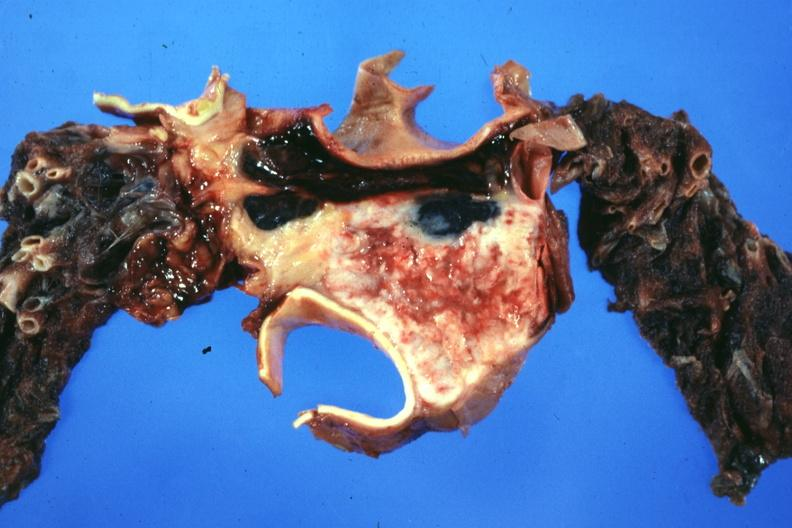how does this image show section?
Answer the question using a single word or phrase. Through mediastinal structure showing tumor about aorta and pulmonary arteries 